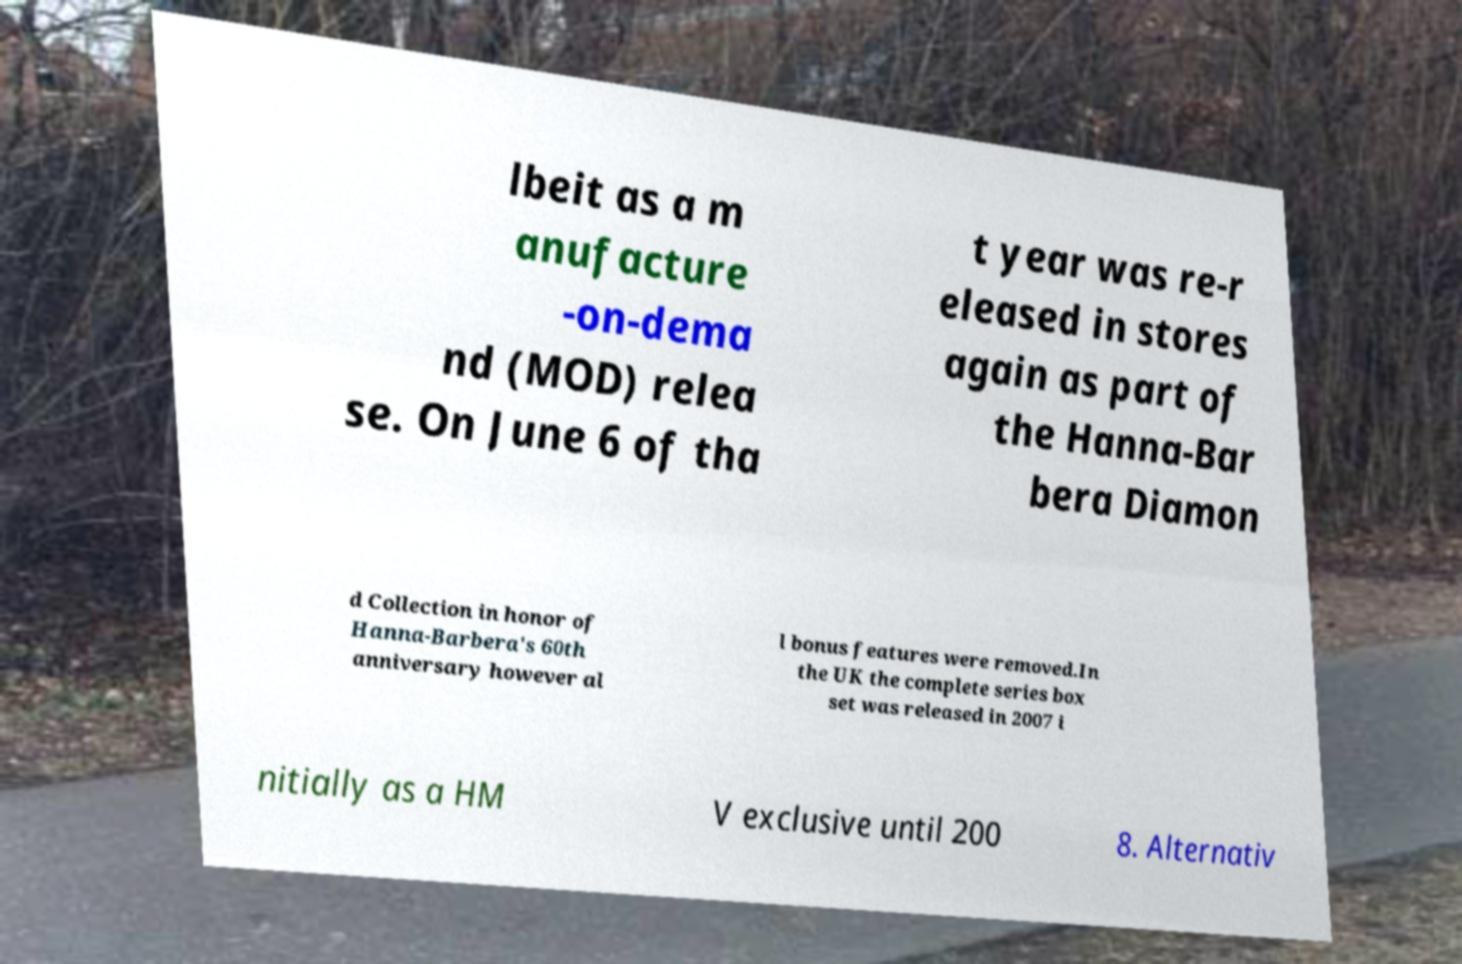Please identify and transcribe the text found in this image. lbeit as a m anufacture -on-dema nd (MOD) relea se. On June 6 of tha t year was re-r eleased in stores again as part of the Hanna-Bar bera Diamon d Collection in honor of Hanna-Barbera's 60th anniversary however al l bonus features were removed.In the UK the complete series box set was released in 2007 i nitially as a HM V exclusive until 200 8. Alternativ 